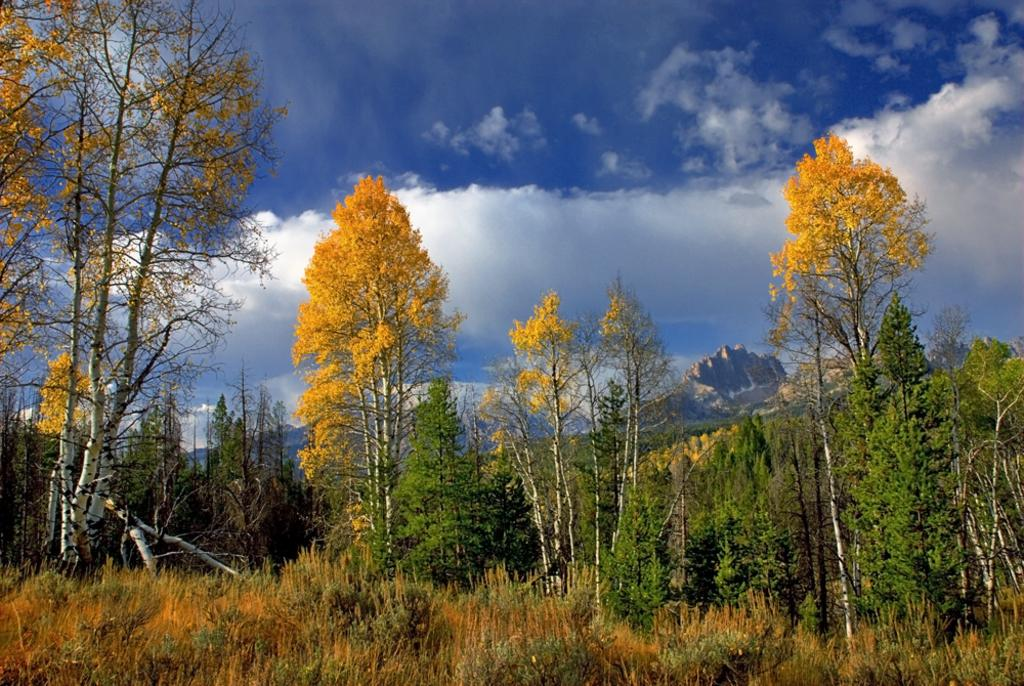What type of ground cover can be seen in the image? The ground is covered with grass. What type of vegetation is present in the image? There are plants and trees in the image. What geographical feature can be seen in the distance? Mountains are visible in the distance. What is visible in the sky in the image? Clouds are present in the sky. What type of stocking is being developed by the team in the image? There is no team or stocking development present in the image. 